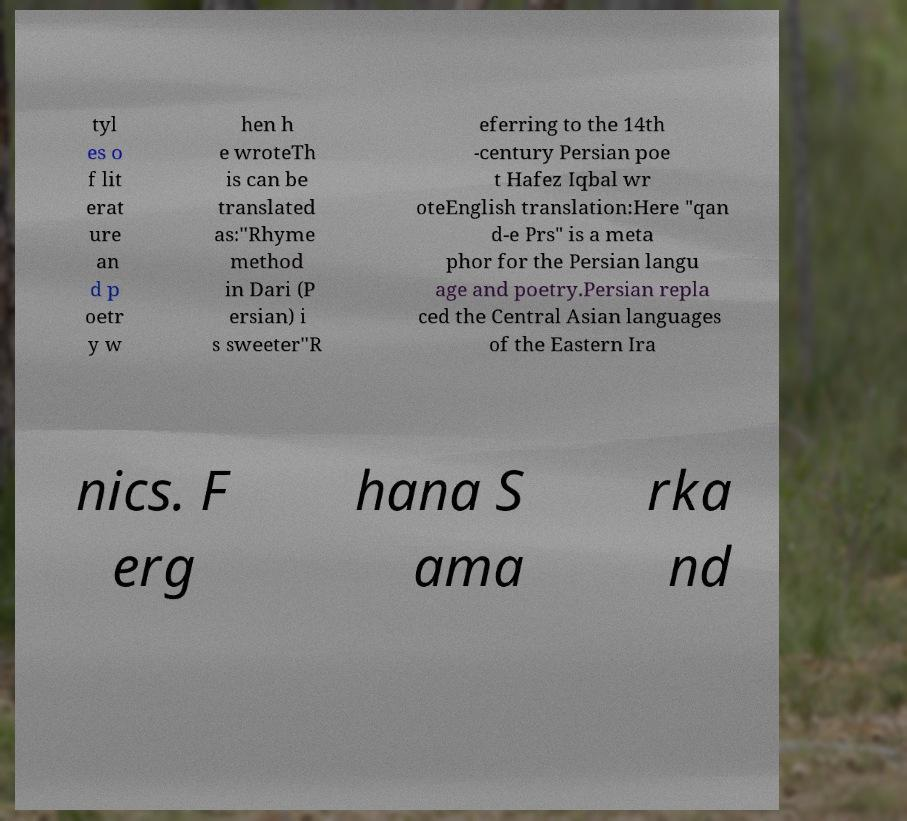Please read and relay the text visible in this image. What does it say? tyl es o f lit erat ure an d p oetr y w hen h e wroteTh is can be translated as:"Rhyme method in Dari (P ersian) i s sweeter"R eferring to the 14th -century Persian poe t Hafez Iqbal wr oteEnglish translation:Here "qan d-e Prs" is a meta phor for the Persian langu age and poetry.Persian repla ced the Central Asian languages of the Eastern Ira nics. F erg hana S ama rka nd 